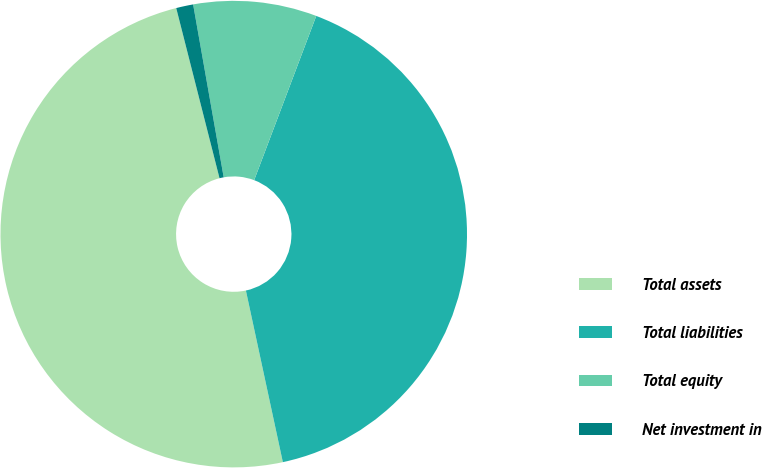<chart> <loc_0><loc_0><loc_500><loc_500><pie_chart><fcel>Total assets<fcel>Total liabilities<fcel>Total equity<fcel>Net investment in<nl><fcel>49.41%<fcel>40.87%<fcel>8.54%<fcel>1.18%<nl></chart> 